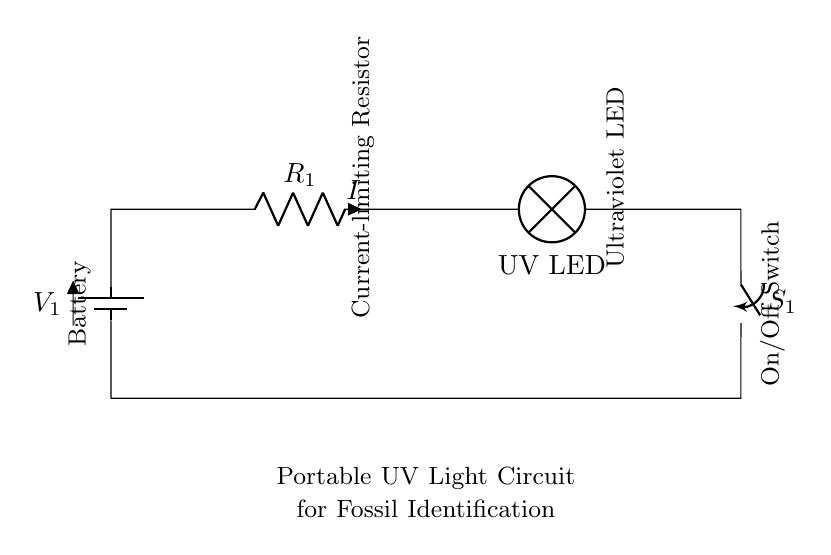What is the voltage source in this circuit? The circuit shows a battery labeled as V1; therefore, the voltage source is the battery.
Answer: battery What type of light is used in this circuit? The circuit includes a lamp labeled as "UV LED," indicating that the light source is a Ultraviolet LED.
Answer: UV LED What component limits the current in this circuit? The resistor labeled as R1 in the circuit is responsible for limiting the current to protect the LED.
Answer: R1 How many components are in this series circuit? Counting the battery, resistor, UV LED, and switch, there are four main components present in the series circuit.
Answer: four What will happen when the switch is open? An open switch interrupts the circuit, causing the current to stop, which will turn off the UV LED.
Answer: current stops If the resistor value is increased, what effect will it have on the current? Increasing the resistor value will decrease the current flowing through the circuit due to Ohm’s law, which states that current is inversely proportional to resistance.
Answer: current decreases What type of circuit is shown here? This circuit is a series circuit because all components are arranged in a single path, causing the same current to flow through each component.
Answer: series circuit 